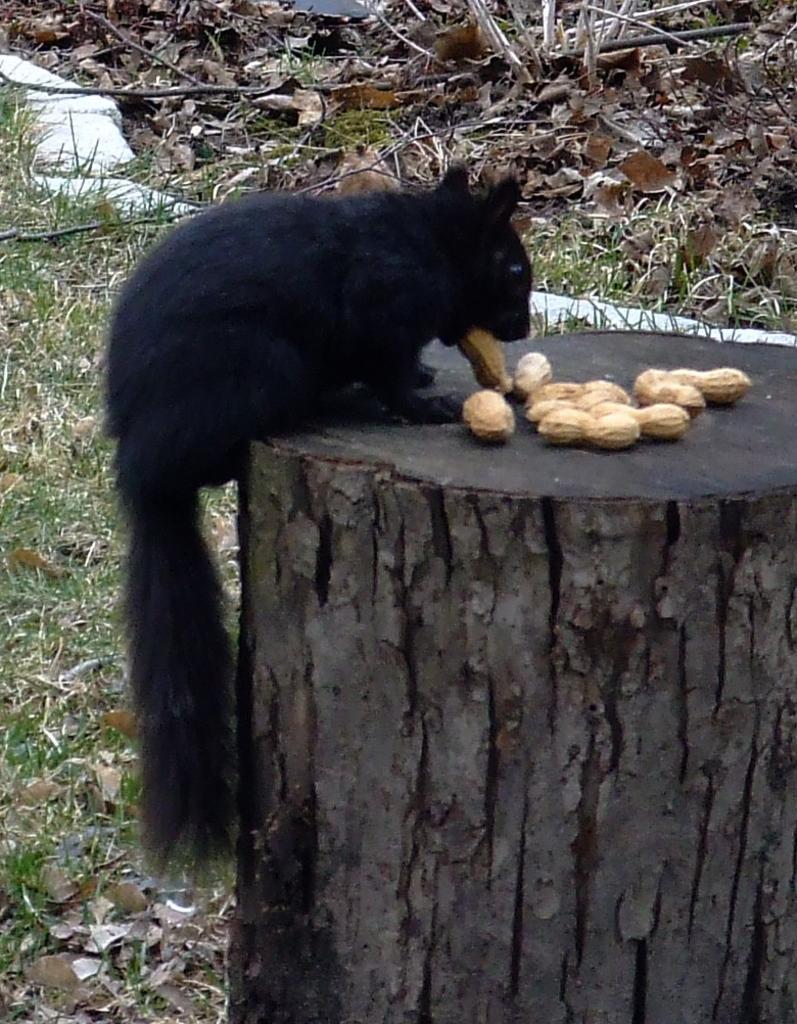Can you describe this image briefly? In this picture we can see a black animal eating groundnuts on a wooden log. On the ground we can see grass and dry leaves. 